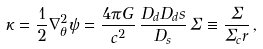<formula> <loc_0><loc_0><loc_500><loc_500>\kappa = \frac { 1 } { 2 } \nabla ^ { 2 } _ { \theta } \psi = \frac { 4 \pi G } { c ^ { 2 } } \, \frac { D _ { d } D _ { d } s } { D _ { s } } \, \Sigma \equiv \frac { \Sigma } { \Sigma _ { c } r } \, ,</formula> 